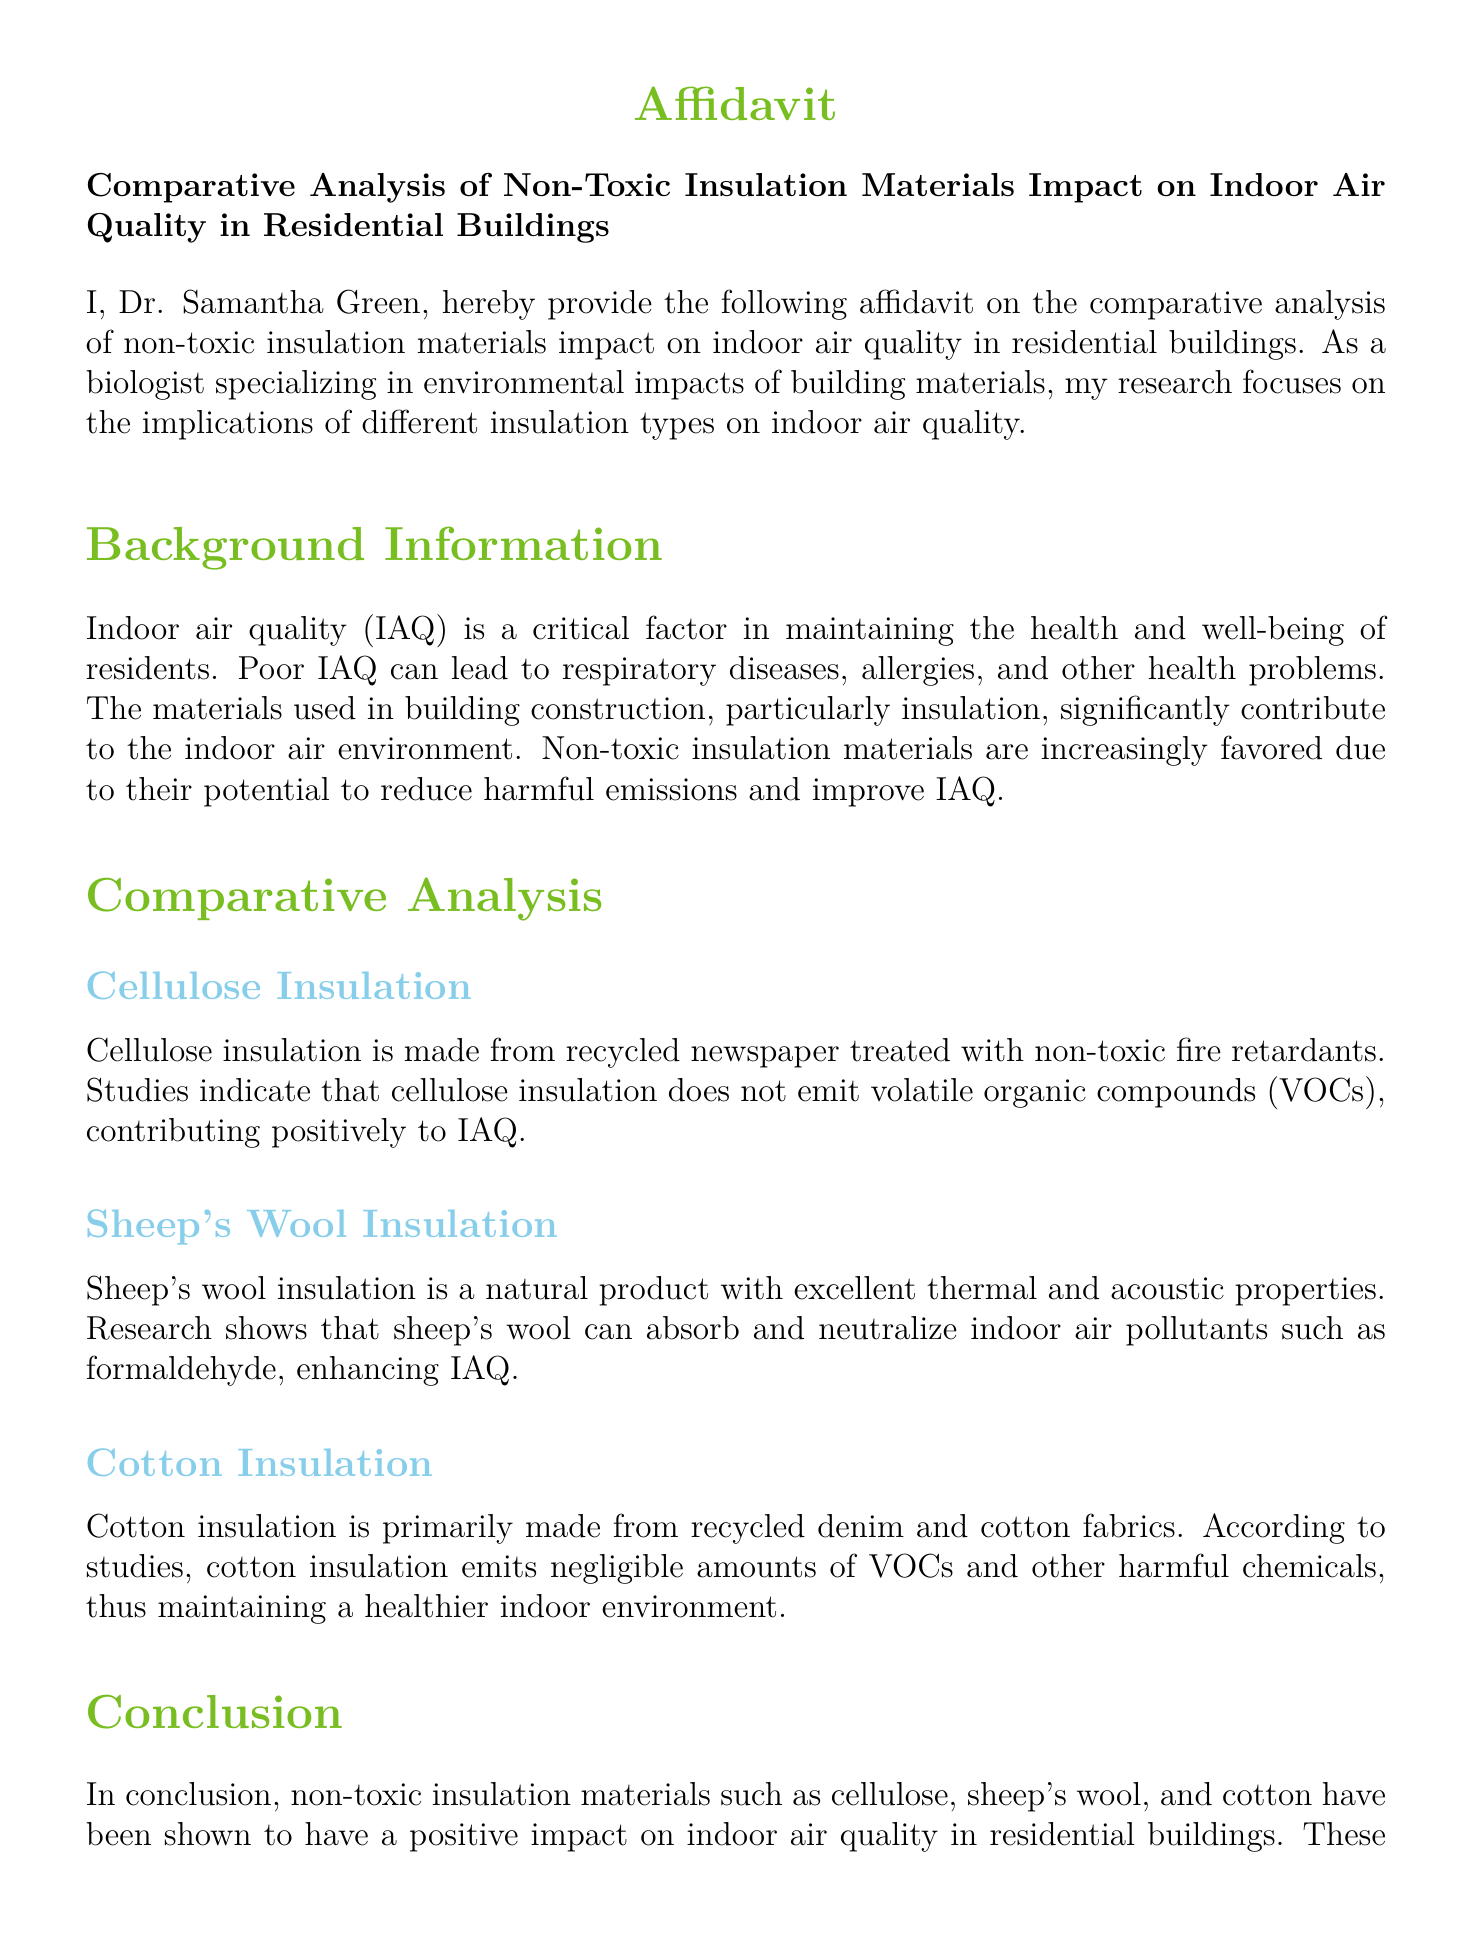What is the title of the affidavit? The title provides the primary focus of the document, which is "Comparative Analysis of Non-Toxic Insulation Materials Impact on Indoor Air Quality in Residential Buildings."
Answer: Comparative Analysis of Non-Toxic Insulation Materials Impact on Indoor Air Quality in Residential Buildings Who authored the affidavit? The document lists the author at the beginning: Dr. Samantha Green.
Answer: Dr. Samantha Green What types of non-toxic insulation materials are discussed? The affidavit mentions three specific types of insulation materials: cellulose, sheep's wool, and cotton.
Answer: Cellulose, sheep's wool, and cotton What is the primary focus of Dr. Samantha Green's research? The research focus is clearly stated as the environmental impacts of different insulation materials on indoor air quality.
Answer: Environmental impacts of building materials Which insulation material absorbs indoor air pollutants? It is mentioned that sheep's wool insulation can absorb and neutralize pollutants like formaldehyde.
Answer: Sheep's wool What does cellulose insulation not emit? According to the document, cellulose insulation does not emit volatile organic compounds (VOCs).
Answer: Volatile organic compounds (VOCs) What is the conclusion regarding non-toxic insulation materials? The document concludes that these materials have a positive impact on indoor air quality by reducing harmful emissions.
Answer: Positive impact on indoor air quality What type of document is this? The document is classified as an affidavit, which is a sworn statement regarding a particular subject.
Answer: Affidavit On which date does Dr. Samantha Green certify the information? The affidavit has a designated space for the date but it is not filled in, indicating the specific date is to be provided later.
Answer: [Date not specified] 